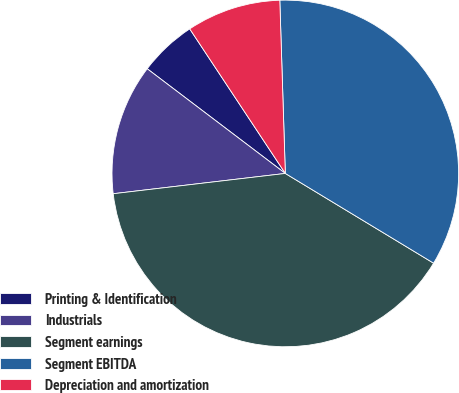Convert chart to OTSL. <chart><loc_0><loc_0><loc_500><loc_500><pie_chart><fcel>Printing & Identification<fcel>Industrials<fcel>Segment earnings<fcel>Segment EBITDA<fcel>Depreciation and amortization<nl><fcel>5.38%<fcel>12.19%<fcel>39.47%<fcel>34.17%<fcel>8.79%<nl></chart> 